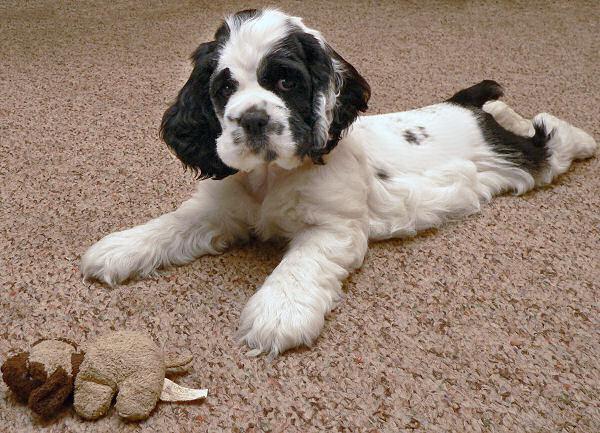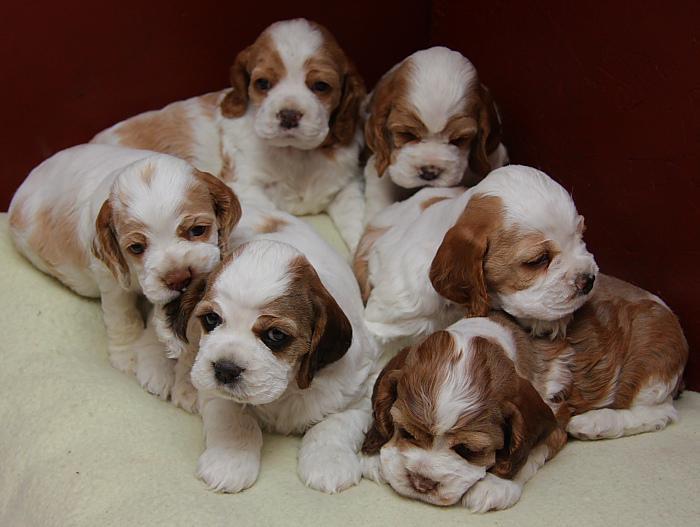The first image is the image on the left, the second image is the image on the right. For the images shown, is this caption "A single puppy is lying on a carpet in one of the images." true? Answer yes or no. Yes. The first image is the image on the left, the second image is the image on the right. Evaluate the accuracy of this statement regarding the images: "The right image contains at least three times as many puppies as the left image.". Is it true? Answer yes or no. Yes. 